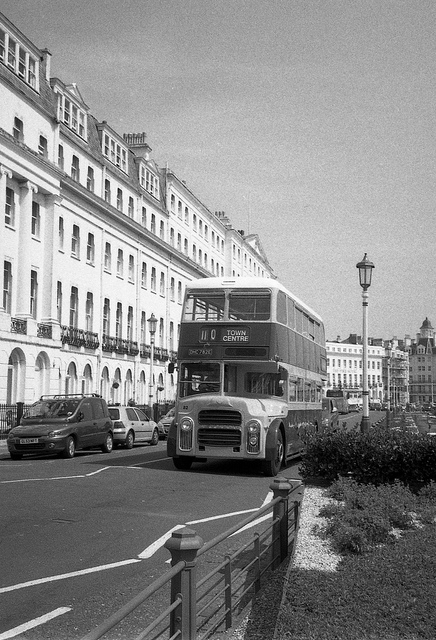Identify the text contained in this image. 11 0 TOWN CENTRE 